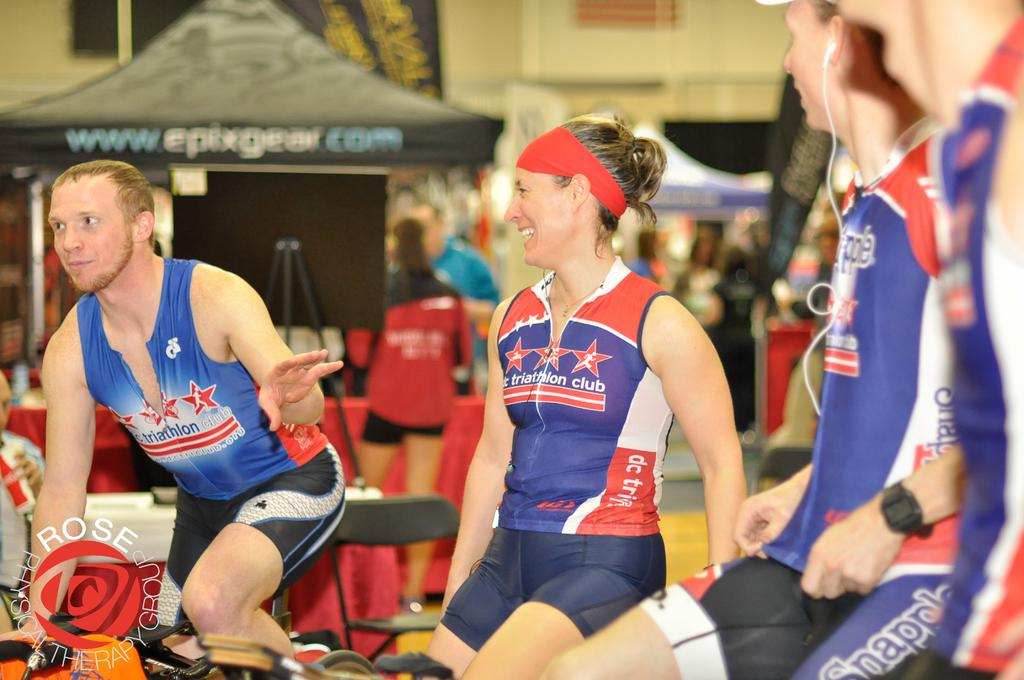Provide a one-sentence caption for the provided image. Several people in bike riding gear are sitting close to each other. 